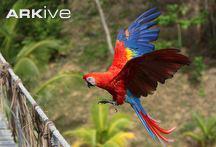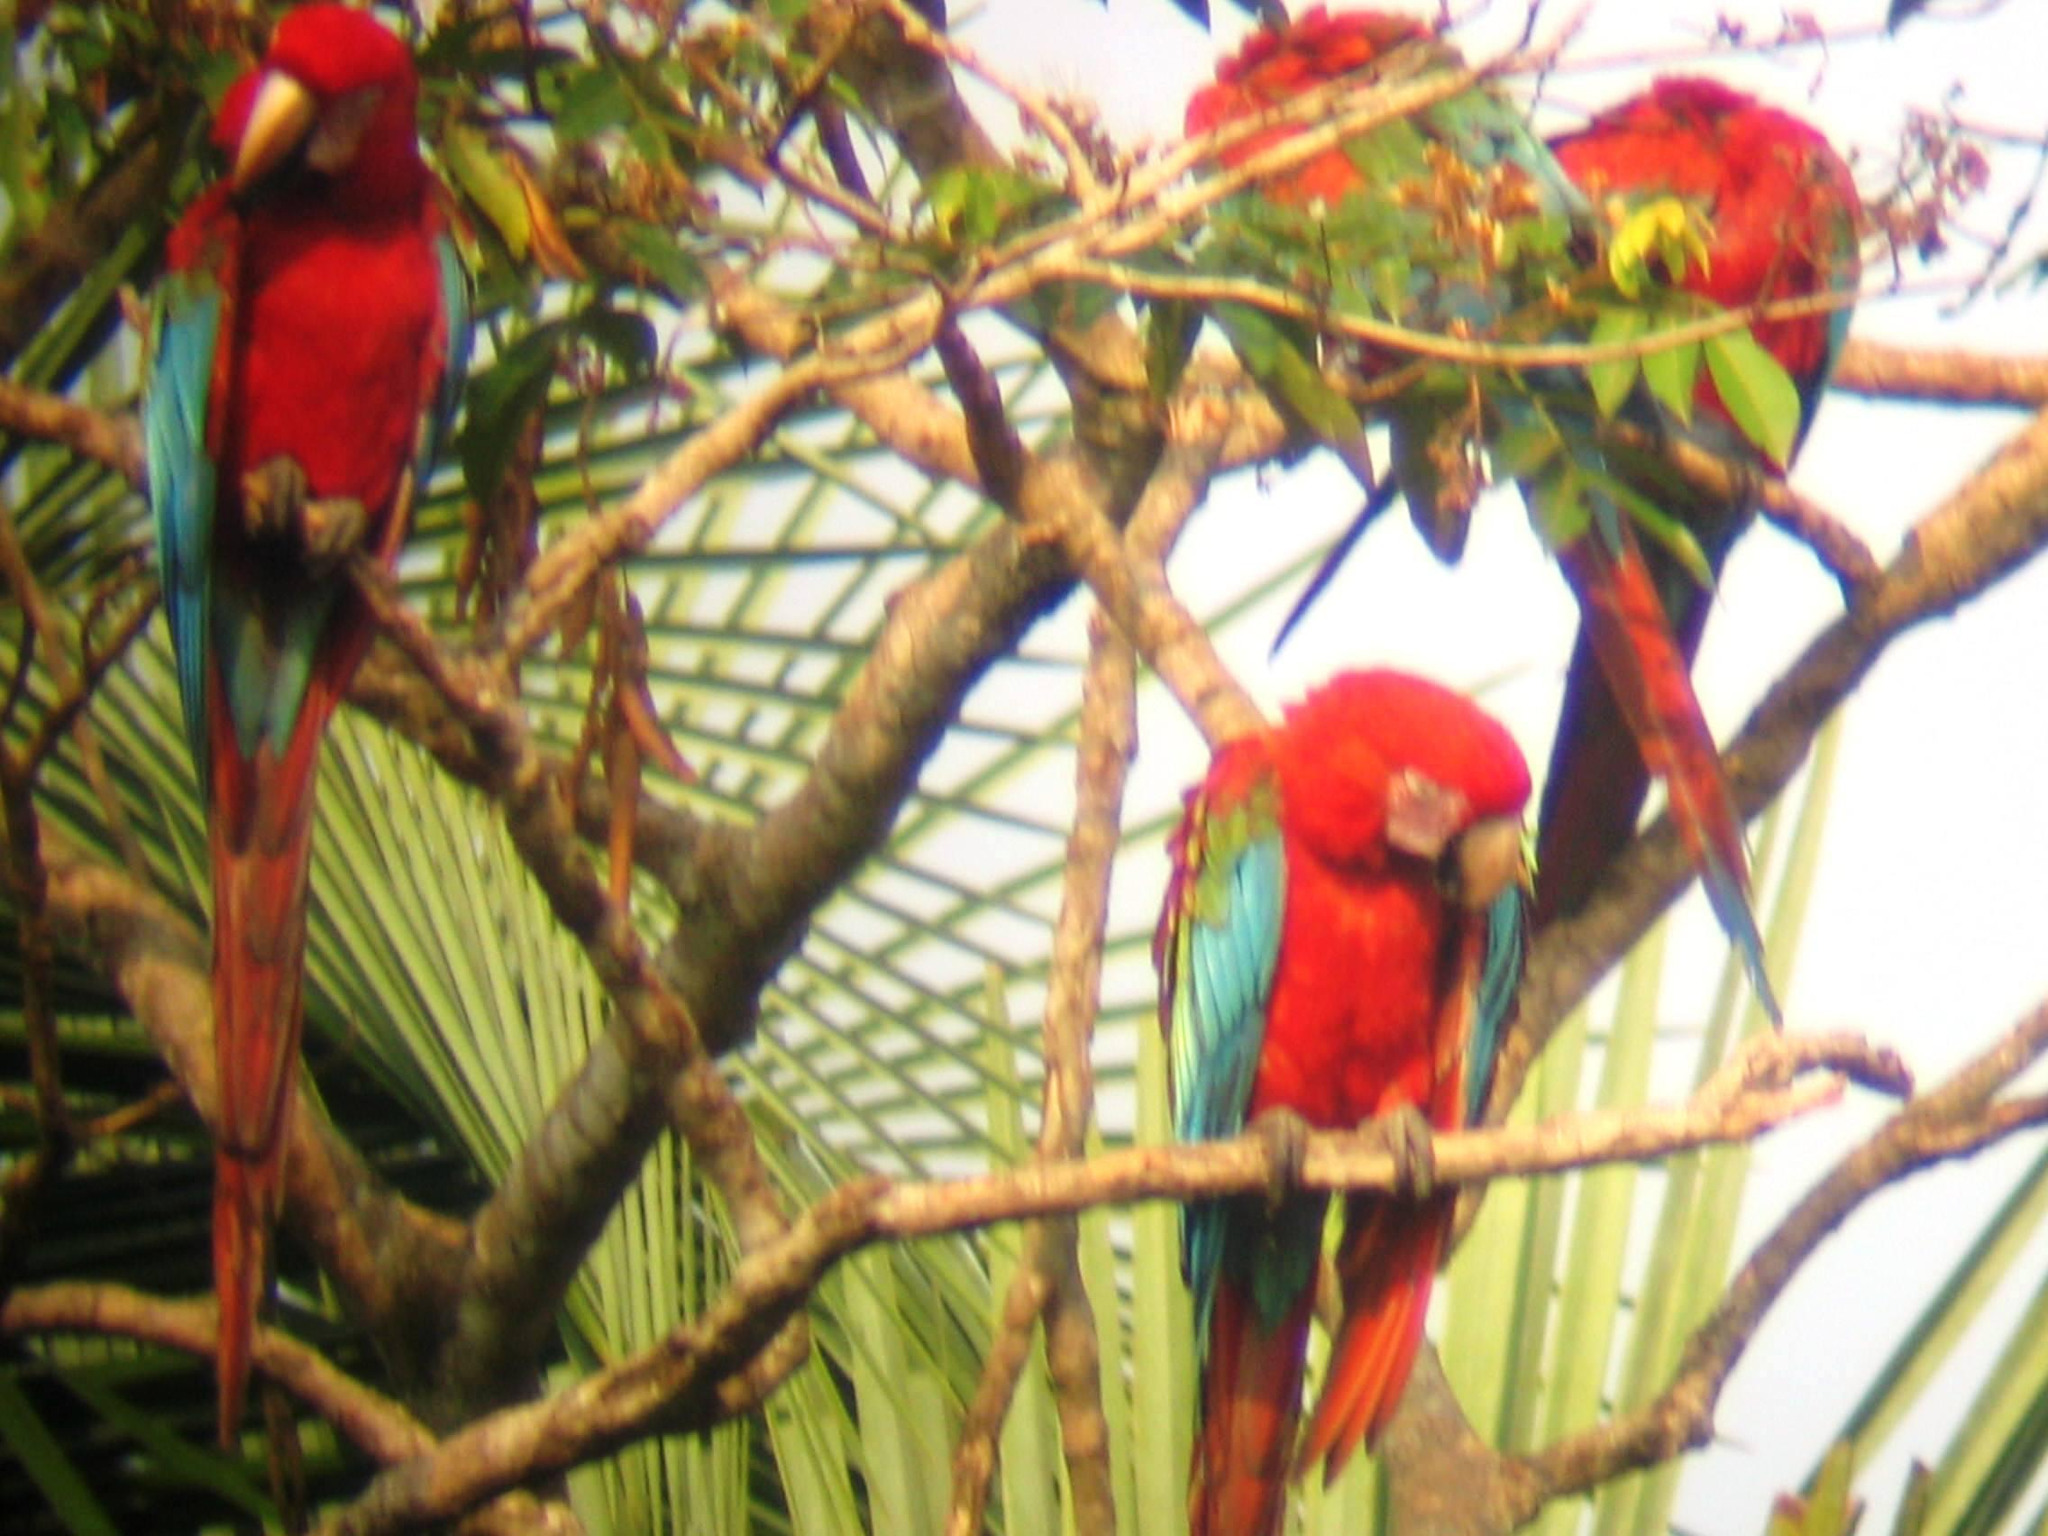The first image is the image on the left, the second image is the image on the right. For the images shown, is this caption "There is no more than one parrot in the left image." true? Answer yes or no. Yes. The first image is the image on the left, the second image is the image on the right. Evaluate the accuracy of this statement regarding the images: "An image shows a single red-headed bird, which is in flight with its body at a diagonal angle.". Is it true? Answer yes or no. Yes. 